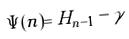<formula> <loc_0><loc_0><loc_500><loc_500>\Psi ( n ) = H _ { n - 1 } - \gamma</formula> 